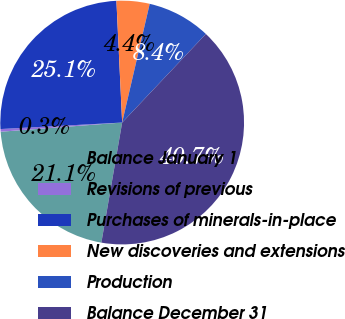<chart> <loc_0><loc_0><loc_500><loc_500><pie_chart><fcel>Balance January 1<fcel>Revisions of previous<fcel>Purchases of minerals-in-place<fcel>New discoveries and extensions<fcel>Production<fcel>Balance December 31<nl><fcel>21.07%<fcel>0.35%<fcel>25.1%<fcel>4.38%<fcel>8.42%<fcel>40.68%<nl></chart> 